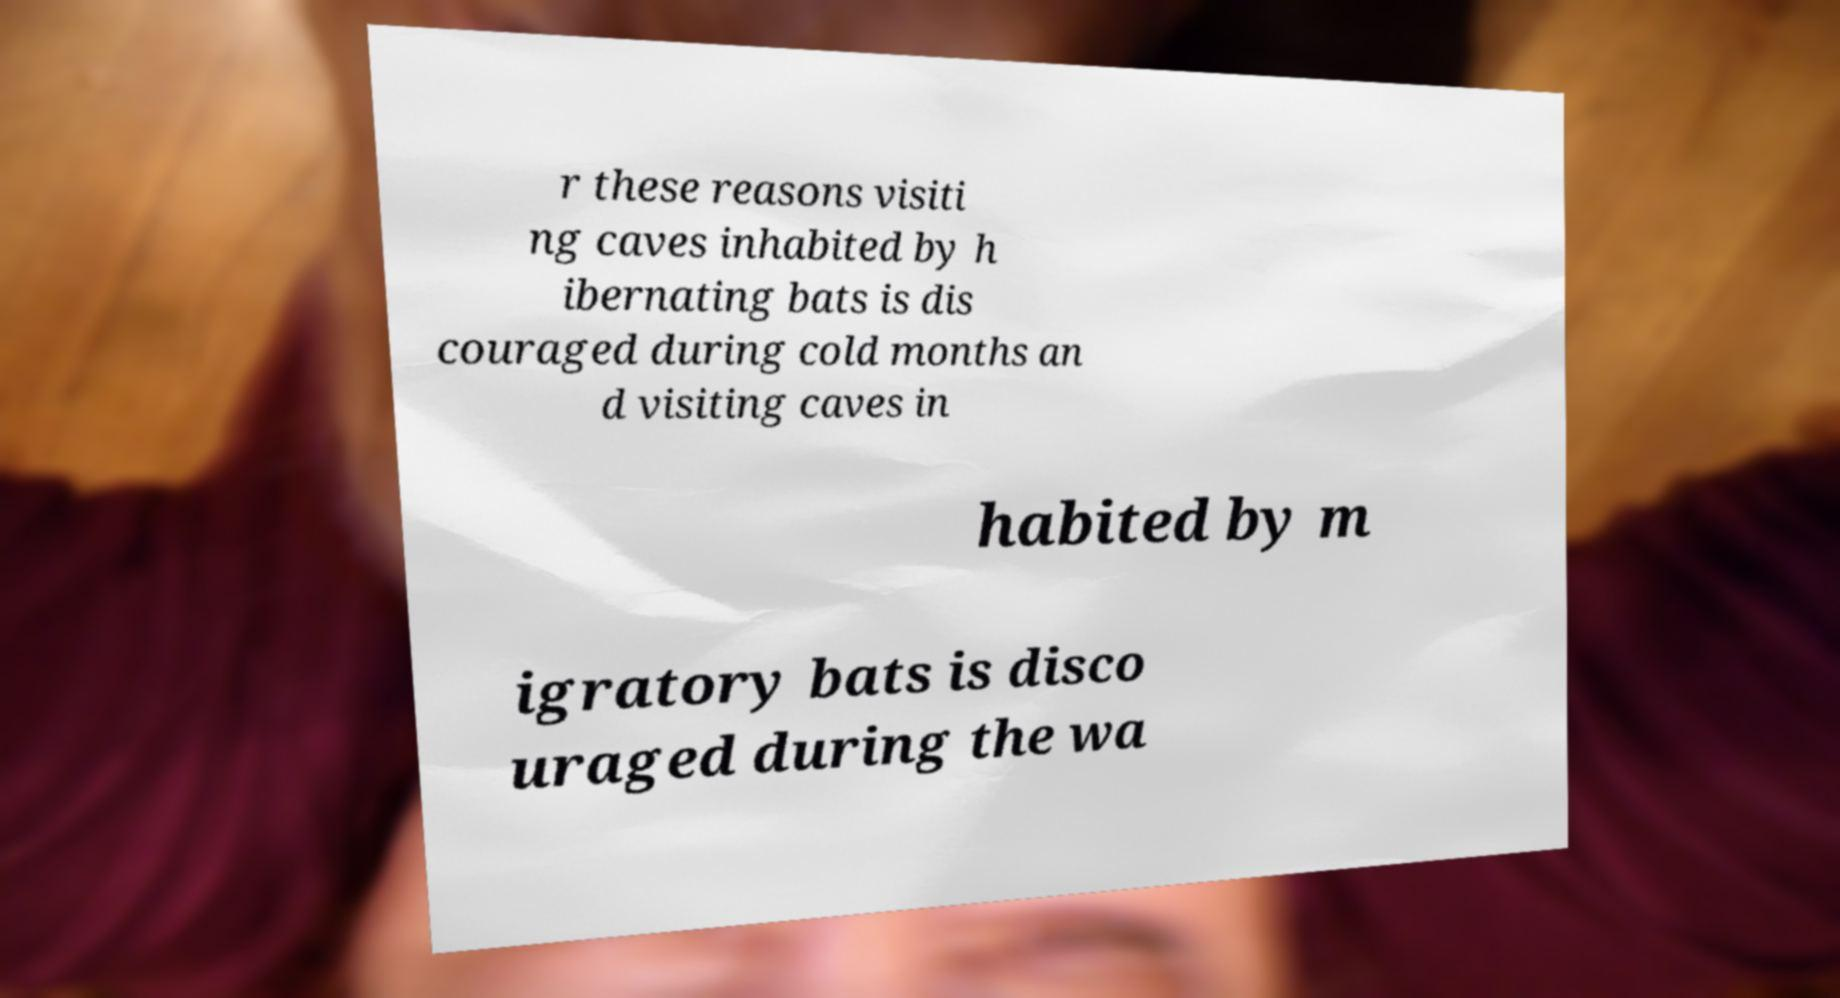Please read and relay the text visible in this image. What does it say? r these reasons visiti ng caves inhabited by h ibernating bats is dis couraged during cold months an d visiting caves in habited by m igratory bats is disco uraged during the wa 